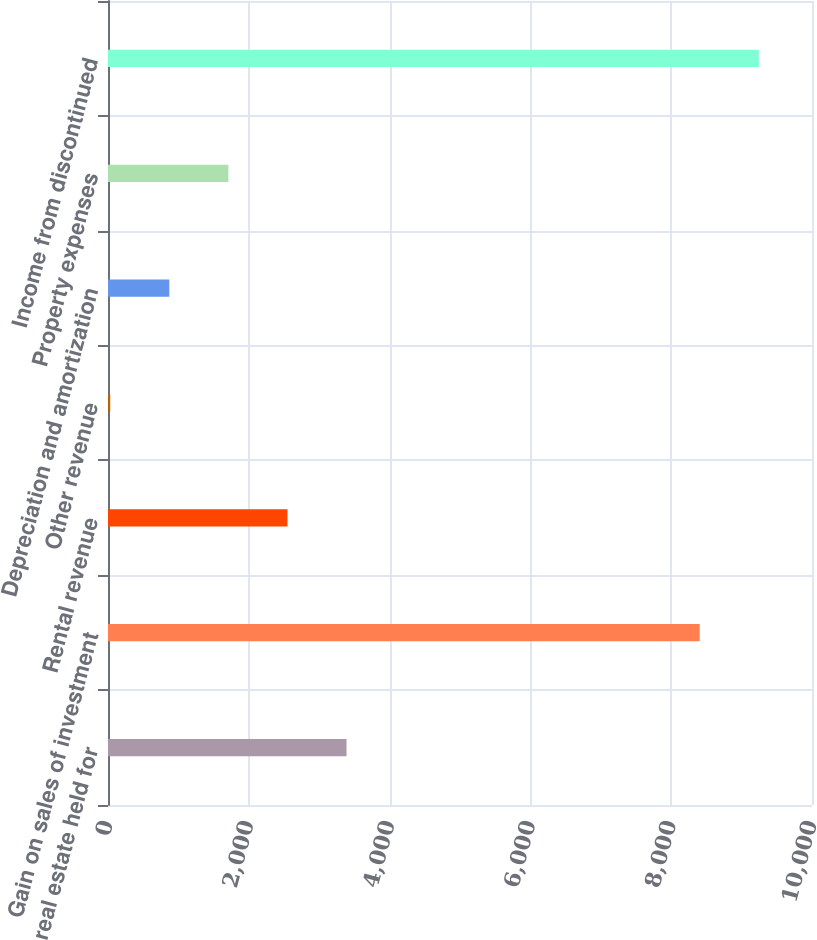Convert chart to OTSL. <chart><loc_0><loc_0><loc_500><loc_500><bar_chart><fcel>real estate held for<fcel>Gain on sales of investment<fcel>Rental revenue<fcel>Other revenue<fcel>Depreciation and amortization<fcel>Property expenses<fcel>Income from discontinued<nl><fcel>3388<fcel>8405<fcel>2549<fcel>32<fcel>871<fcel>1710<fcel>9244<nl></chart> 